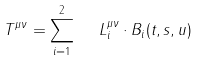<formula> <loc_0><loc_0><loc_500><loc_500>T ^ { \mu \nu } = \sum _ { i = 1 } ^ { 2 } \ \ L ^ { \mu \nu } _ { i } \cdot B _ { i } ( t , s , u )</formula> 